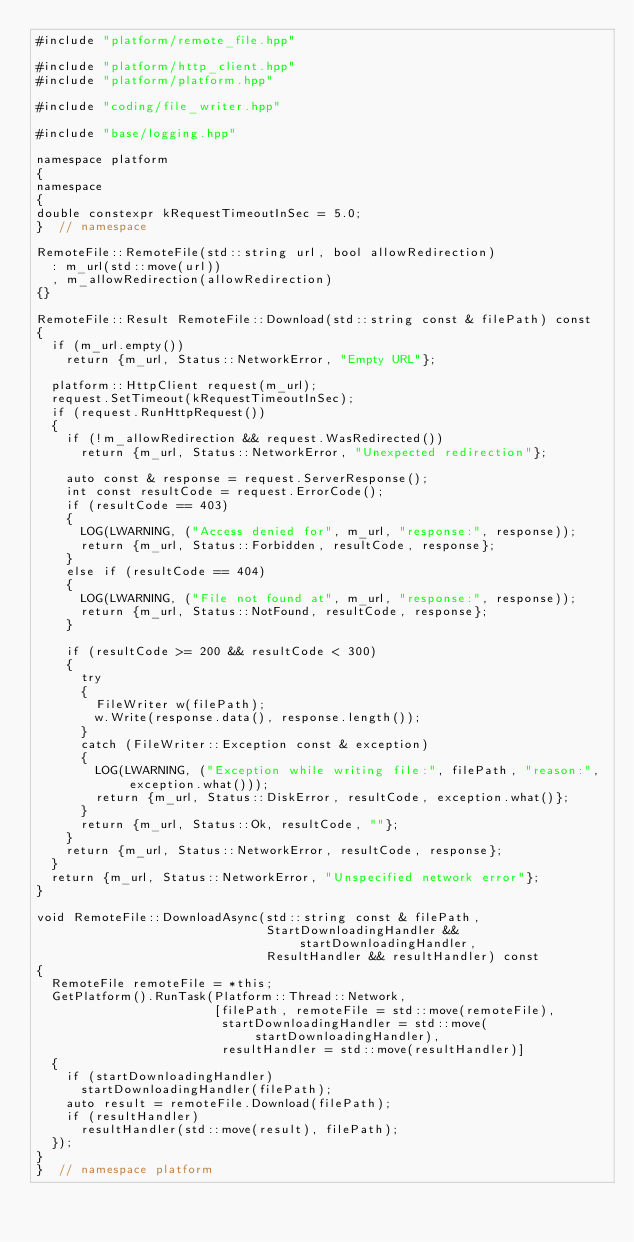<code> <loc_0><loc_0><loc_500><loc_500><_C++_>#include "platform/remote_file.hpp"

#include "platform/http_client.hpp"
#include "platform/platform.hpp"

#include "coding/file_writer.hpp"

#include "base/logging.hpp"

namespace platform
{
namespace
{
double constexpr kRequestTimeoutInSec = 5.0;
}  // namespace

RemoteFile::RemoteFile(std::string url, bool allowRedirection)
  : m_url(std::move(url))
  , m_allowRedirection(allowRedirection)
{}

RemoteFile::Result RemoteFile::Download(std::string const & filePath) const
{
  if (m_url.empty())
    return {m_url, Status::NetworkError, "Empty URL"};

  platform::HttpClient request(m_url);
  request.SetTimeout(kRequestTimeoutInSec);
  if (request.RunHttpRequest())
  {
    if (!m_allowRedirection && request.WasRedirected())
      return {m_url, Status::NetworkError, "Unexpected redirection"};

    auto const & response = request.ServerResponse();
    int const resultCode = request.ErrorCode();
    if (resultCode == 403)
    {
      LOG(LWARNING, ("Access denied for", m_url, "response:", response));
      return {m_url, Status::Forbidden, resultCode, response};
    }
    else if (resultCode == 404)
    {
      LOG(LWARNING, ("File not found at", m_url, "response:", response));
      return {m_url, Status::NotFound, resultCode, response};
    }

    if (resultCode >= 200 && resultCode < 300)
    {
      try
      {
        FileWriter w(filePath);
        w.Write(response.data(), response.length());
      }
      catch (FileWriter::Exception const & exception)
      {
        LOG(LWARNING, ("Exception while writing file:", filePath, "reason:", exception.what()));
        return {m_url, Status::DiskError, resultCode, exception.what()};
      }
      return {m_url, Status::Ok, resultCode, ""};
    }
    return {m_url, Status::NetworkError, resultCode, response};
  }
  return {m_url, Status::NetworkError, "Unspecified network error"};
}

void RemoteFile::DownloadAsync(std::string const & filePath,
                               StartDownloadingHandler && startDownloadingHandler,
                               ResultHandler && resultHandler) const
{
  RemoteFile remoteFile = *this;
  GetPlatform().RunTask(Platform::Thread::Network,
                        [filePath, remoteFile = std::move(remoteFile),
                         startDownloadingHandler = std::move(startDownloadingHandler),
                         resultHandler = std::move(resultHandler)]
  {
    if (startDownloadingHandler)
      startDownloadingHandler(filePath);
    auto result = remoteFile.Download(filePath);
    if (resultHandler)
      resultHandler(std::move(result), filePath);
  });
}
}  // namespace platform
</code> 